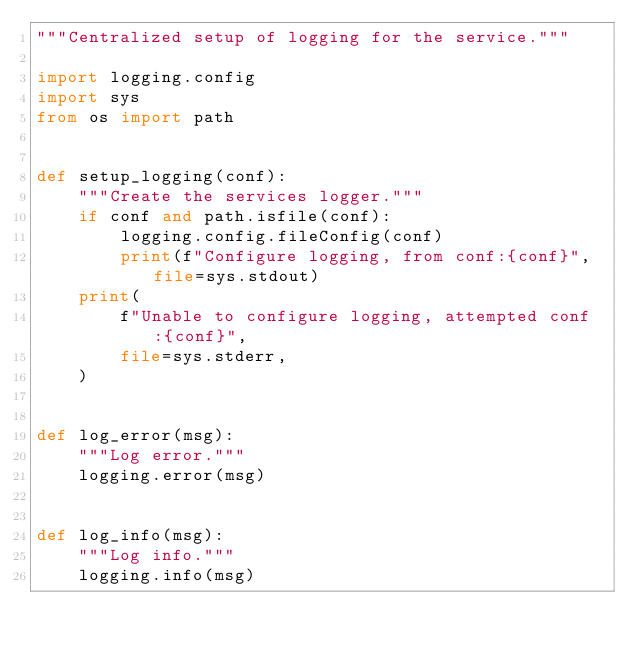Convert code to text. <code><loc_0><loc_0><loc_500><loc_500><_Python_>"""Centralized setup of logging for the service."""

import logging.config
import sys
from os import path


def setup_logging(conf):
    """Create the services logger."""
    if conf and path.isfile(conf):
        logging.config.fileConfig(conf)
        print(f"Configure logging, from conf:{conf}", file=sys.stdout)
    print(
        f"Unable to configure logging, attempted conf:{conf}",
        file=sys.stderr,
    )


def log_error(msg):
    """Log error."""
    logging.error(msg)


def log_info(msg):
    """Log info."""
    logging.info(msg)
</code> 